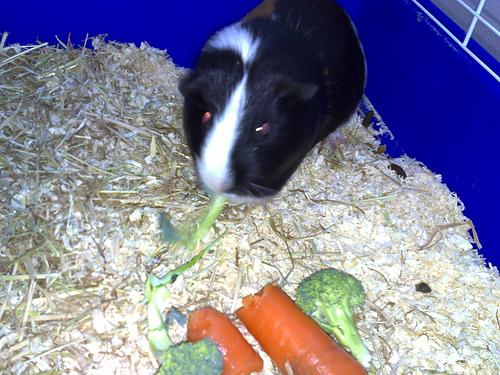Provide a journalistic headline-style caption for the image. Black and White Guinea Pig Enjoys Fresh Veggie Spread in Vibrant Enclosure Mention the main subject in the image along with what it is consuming with its noticeable feature. A black and white guinea pig with red eyes is eating green broccoli and orange carrots in its enclosure. Provide a simple description of the central object and its action in the image. A black and white guinea pig is eating vegetables in its cage. Provide a caption for the image by focusing on the food items and the animal. Guinea Pig's Delicious Feast: Carrots Savored, Broccoli Preferred Comment on the image by describing the guinea pig's actions, appearance, and setting. Adorable black and white guinea pig caught in the act of munching on some tasty veggies in its colorful, comfy cage! Use a poetic style to depict the primary subject and their activity in the image. Amidst a colorful feast of green and orange, a monochrome guinea pig finds delight as it nibbles and chews the treats that lie before it. Explain the scene of the image including the main object, its food, and its environment. A black and white guinea pig enjoys a meal of fresh orange carrots and green broccoli, surrounded by straw bedding and a blue enclosure. Using a storytelling tone, briefly narrate the situation depicted in the image. Once upon a time, in a blue-walled cage, a guinea pig with stunning red eyes embarked on a culinary adventure, savoring succulent carrots and broccoli. Describe the contents of the cage in the image using short clauses. Cage with blue walls, white wire top, straw bedding, wood chips, hay, two carrots, green broccoli, and a black and white guinea pig eating. Using an informal tone, describe the animal in the image and its setting. This cute black and white guinea pig with a wee white stripe on its head is chowing down on some veggies in its cozy blue cage! 